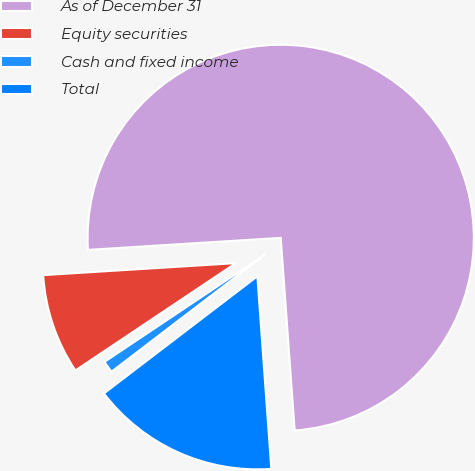Convert chart. <chart><loc_0><loc_0><loc_500><loc_500><pie_chart><fcel>As of December 31<fcel>Equity securities<fcel>Cash and fixed income<fcel>Total<nl><fcel>74.84%<fcel>8.39%<fcel>1.0%<fcel>15.77%<nl></chart> 